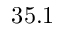<formula> <loc_0><loc_0><loc_500><loc_500>3 5 . 1</formula> 